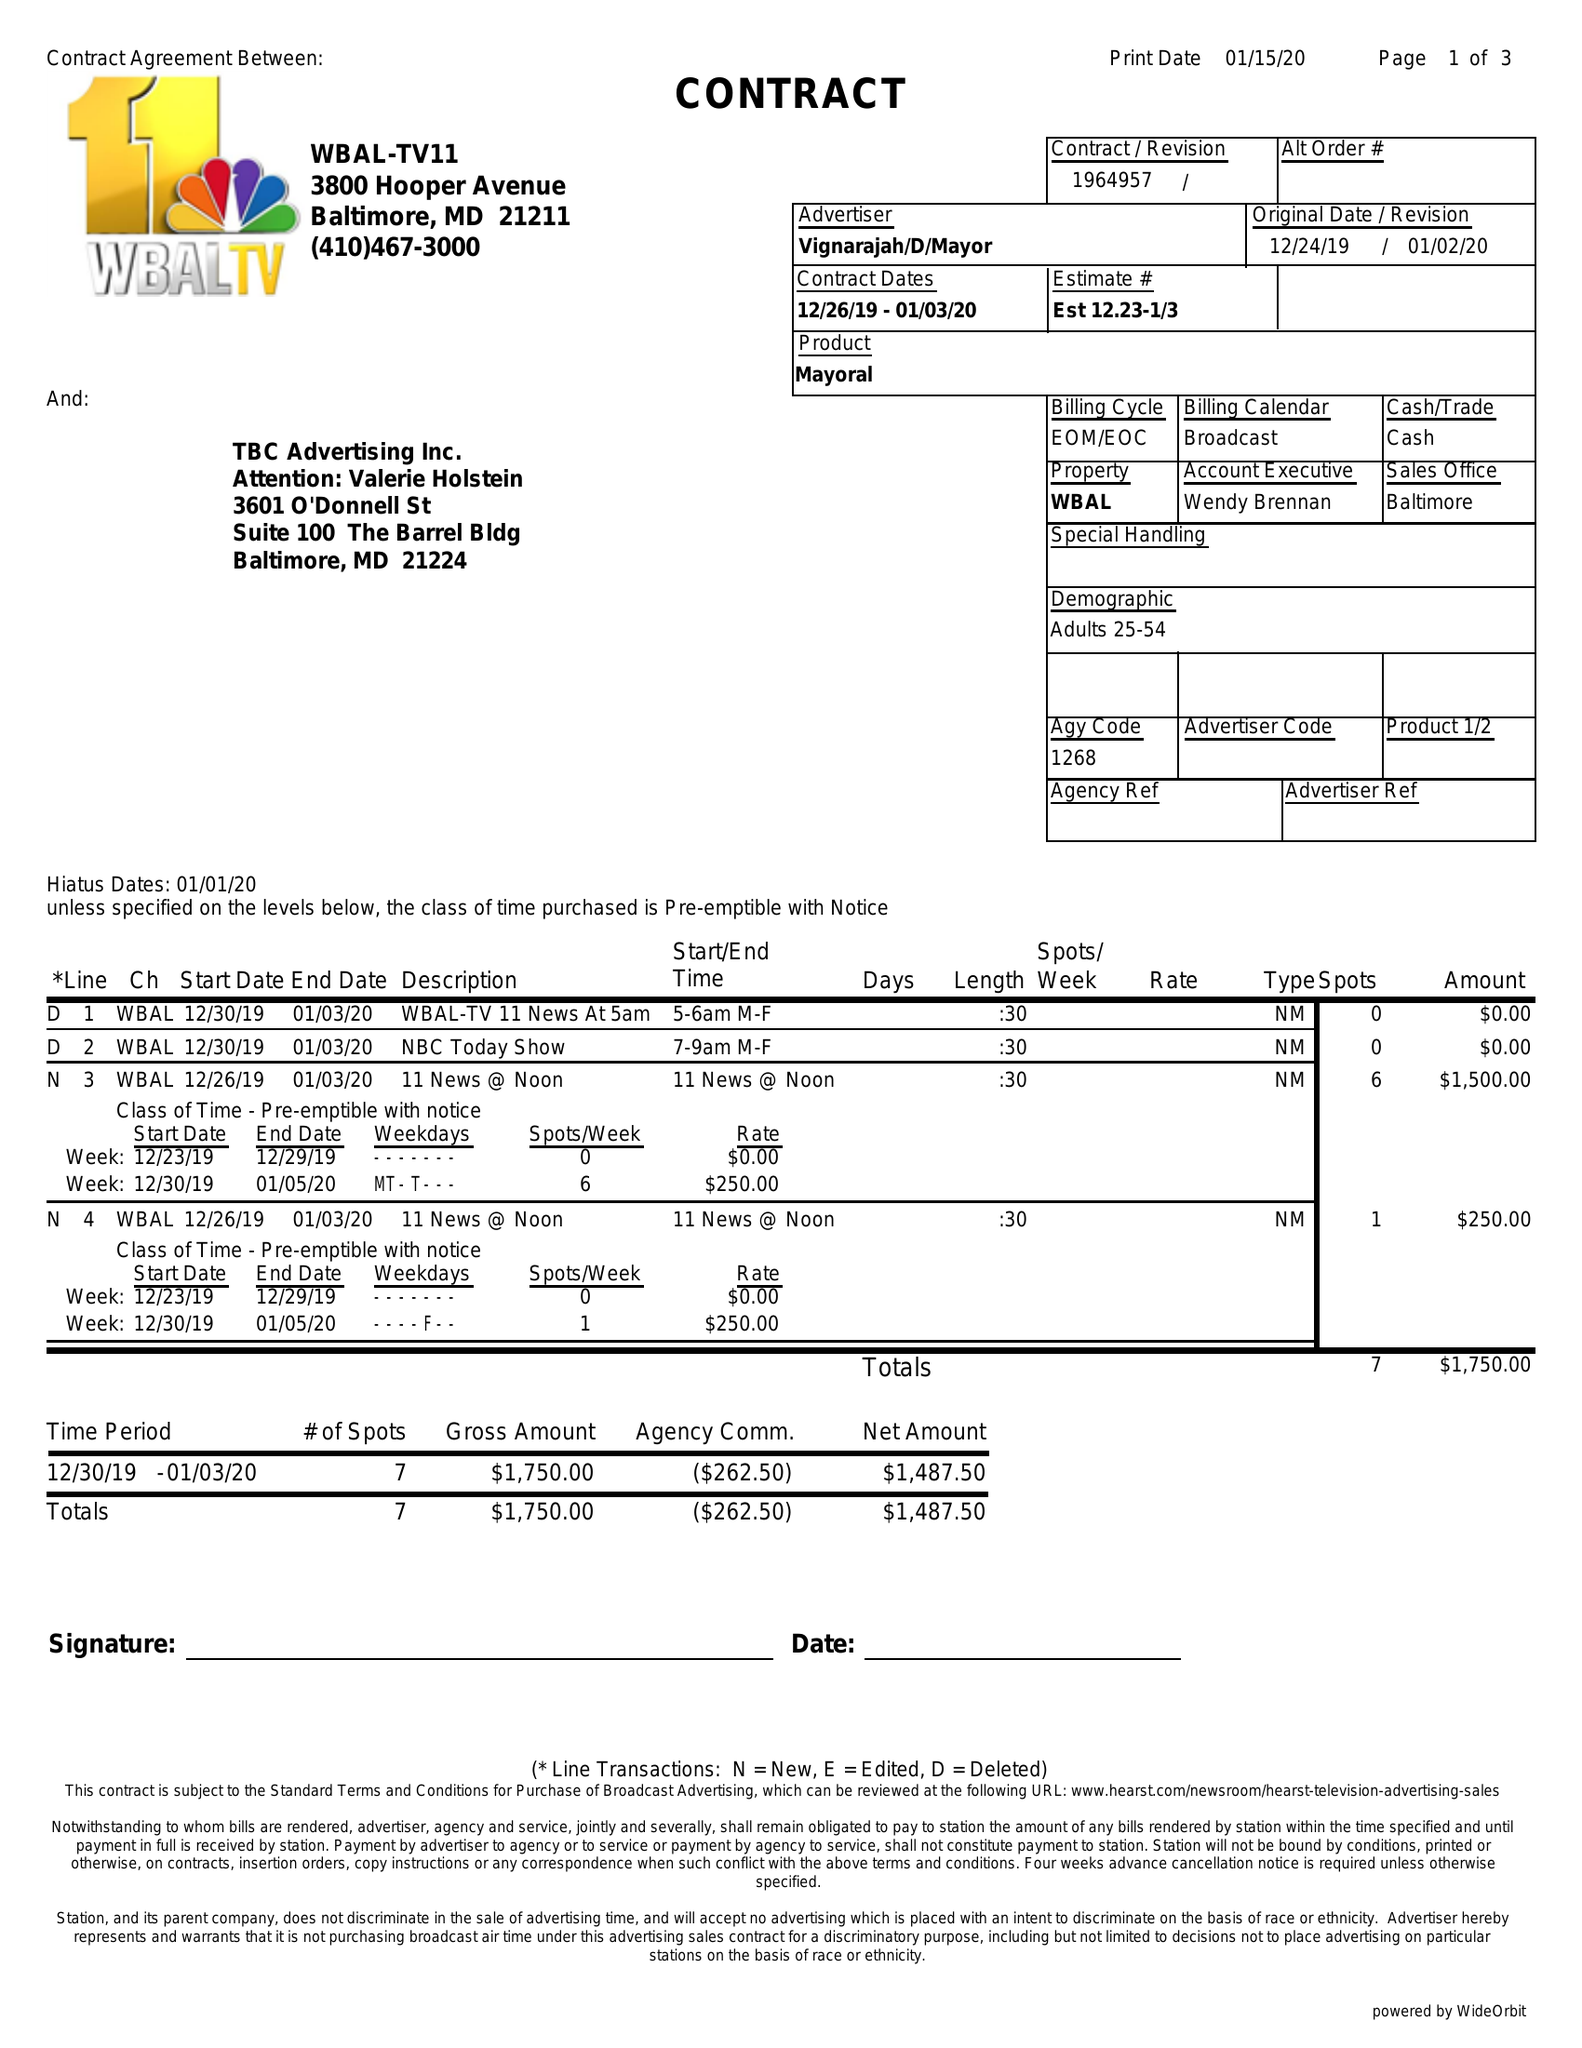What is the value for the gross_amount?
Answer the question using a single word or phrase. 1750.00 